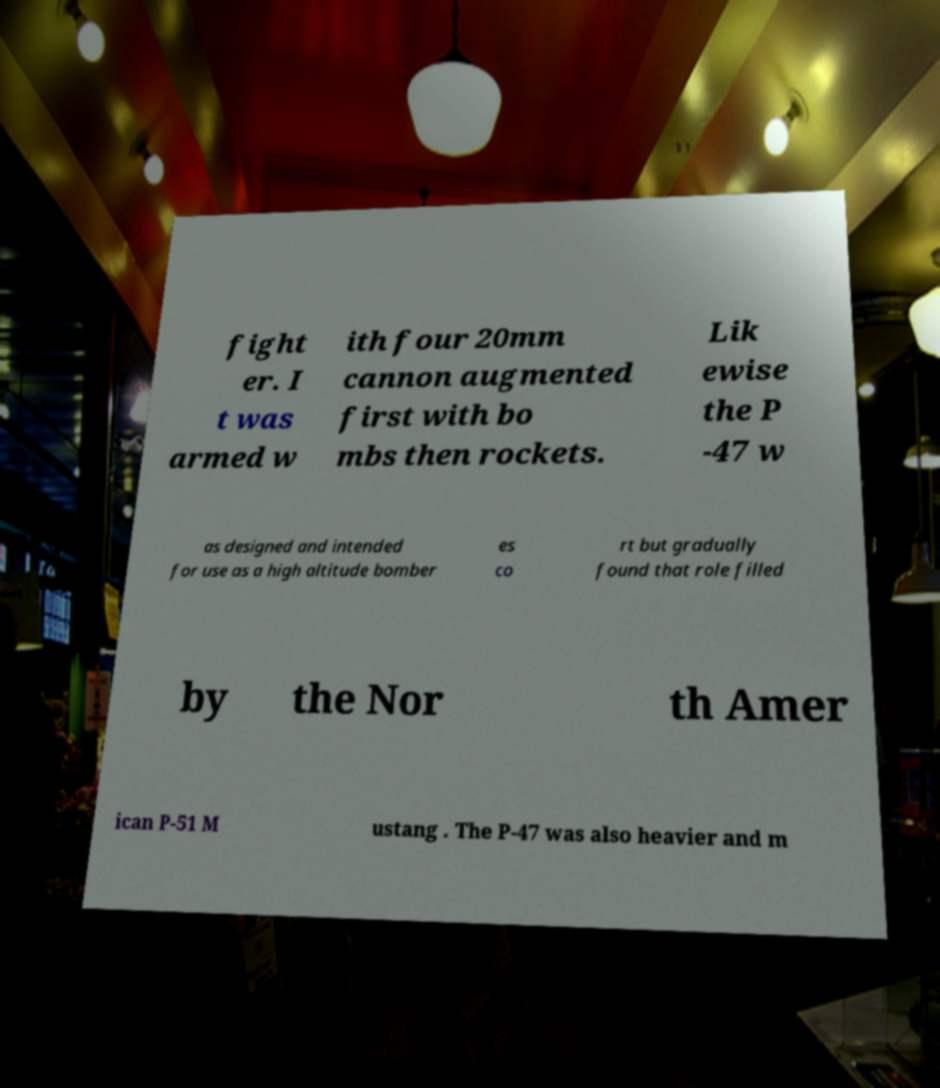Could you extract and type out the text from this image? fight er. I t was armed w ith four 20mm cannon augmented first with bo mbs then rockets. Lik ewise the P -47 w as designed and intended for use as a high altitude bomber es co rt but gradually found that role filled by the Nor th Amer ican P-51 M ustang . The P-47 was also heavier and m 